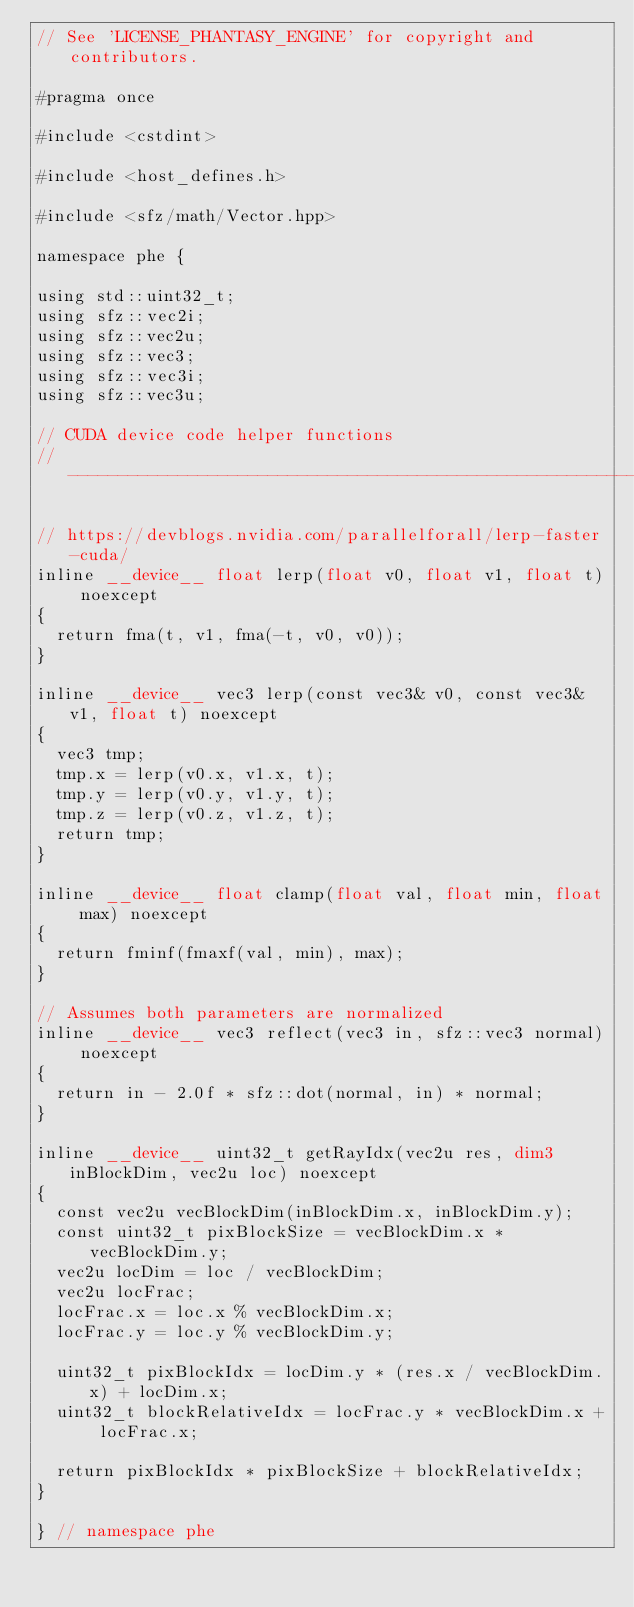<code> <loc_0><loc_0><loc_500><loc_500><_Cuda_>// See 'LICENSE_PHANTASY_ENGINE' for copyright and contributors.

#pragma once

#include <cstdint>

#include <host_defines.h>

#include <sfz/math/Vector.hpp>

namespace phe {

using std::uint32_t;
using sfz::vec2i;
using sfz::vec2u;
using sfz::vec3;
using sfz::vec3i;
using sfz::vec3u;

// CUDA device code helper functions
// ------------------------------------------------------------------------------------------------

// https://devblogs.nvidia.com/parallelforall/lerp-faster-cuda/
inline __device__ float lerp(float v0, float v1, float t) noexcept
{
	return fma(t, v1, fma(-t, v0, v0));
}

inline __device__ vec3 lerp(const vec3& v0, const vec3& v1, float t) noexcept
{
	vec3 tmp;
	tmp.x = lerp(v0.x, v1.x, t);
	tmp.y = lerp(v0.y, v1.y, t);
	tmp.z = lerp(v0.z, v1.z, t);
	return tmp;
}

inline __device__ float clamp(float val, float min, float max) noexcept
{
	return fminf(fmaxf(val, min), max);
}

// Assumes both parameters are normalized
inline __device__ vec3 reflect(vec3 in, sfz::vec3 normal) noexcept
{
	return in - 2.0f * sfz::dot(normal, in) * normal;
}

inline __device__ uint32_t getRayIdx(vec2u res, dim3 inBlockDim, vec2u loc) noexcept
{
	const vec2u vecBlockDim(inBlockDim.x, inBlockDim.y);
	const uint32_t pixBlockSize = vecBlockDim.x * vecBlockDim.y;
	vec2u locDim = loc / vecBlockDim;
	vec2u locFrac;
	locFrac.x = loc.x % vecBlockDim.x;
	locFrac.y = loc.y % vecBlockDim.y;

	uint32_t pixBlockIdx = locDim.y * (res.x / vecBlockDim.x) + locDim.x;
	uint32_t blockRelativeIdx = locFrac.y * vecBlockDim.x + locFrac.x;

	return pixBlockIdx * pixBlockSize + blockRelativeIdx;
}

} // namespace phe
</code> 